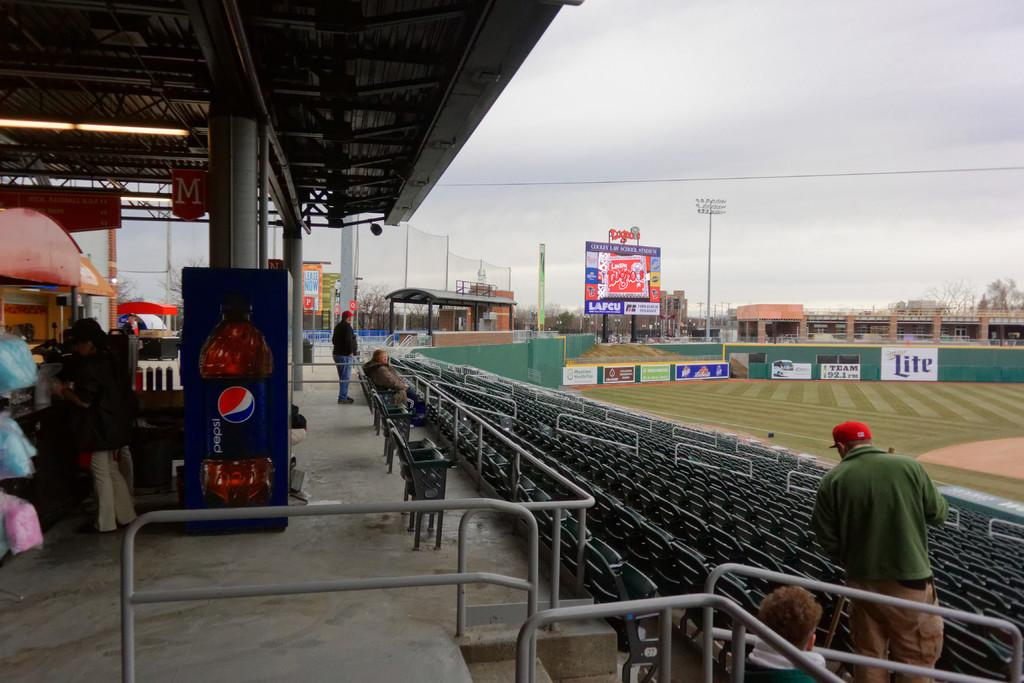<image>
Render a clear and concise summary of the photo. an almost empty section of stands at a baseball field sponsored by miller lite 